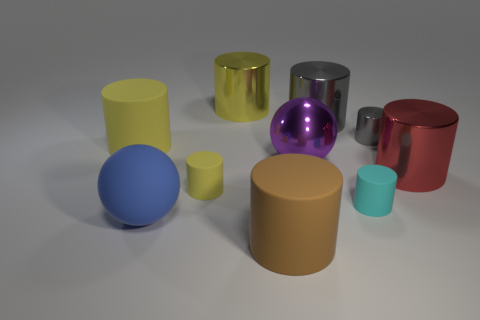What material is the yellow cylinder behind the rubber object that is on the left side of the blue thing to the left of the big yellow metal cylinder made of?
Keep it short and to the point. Metal. There is a brown thing that is the same shape as the cyan object; what material is it?
Your answer should be compact. Rubber. There is a sphere left of the big object that is behind the gray cylinder left of the tiny cyan matte object; how big is it?
Ensure brevity in your answer.  Large. Does the blue thing have the same size as the cyan matte thing?
Your answer should be compact. No. What is the tiny cylinder that is behind the large object right of the small cyan cylinder made of?
Offer a terse response. Metal. Is the shape of the tiny thing that is behind the metal ball the same as the blue rubber thing that is left of the purple metal thing?
Offer a very short reply. No. Are there an equal number of big shiny balls on the left side of the large yellow matte cylinder and big cylinders?
Your answer should be very brief. No. There is a sphere to the left of the yellow metallic object; are there any brown objects that are right of it?
Offer a terse response. Yes. Is there anything else of the same color as the big metallic ball?
Make the answer very short. No. Is the material of the tiny thing behind the purple metallic object the same as the tiny yellow cylinder?
Your response must be concise. No. 